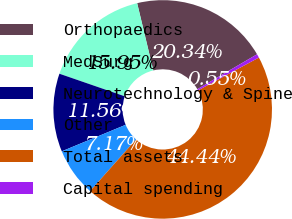Convert chart to OTSL. <chart><loc_0><loc_0><loc_500><loc_500><pie_chart><fcel>Orthopaedics<fcel>MedSurg<fcel>Neurotechnology & Spine<fcel>Other<fcel>Total assets<fcel>Capital spending<nl><fcel>20.34%<fcel>15.95%<fcel>11.56%<fcel>7.17%<fcel>44.44%<fcel>0.55%<nl></chart> 